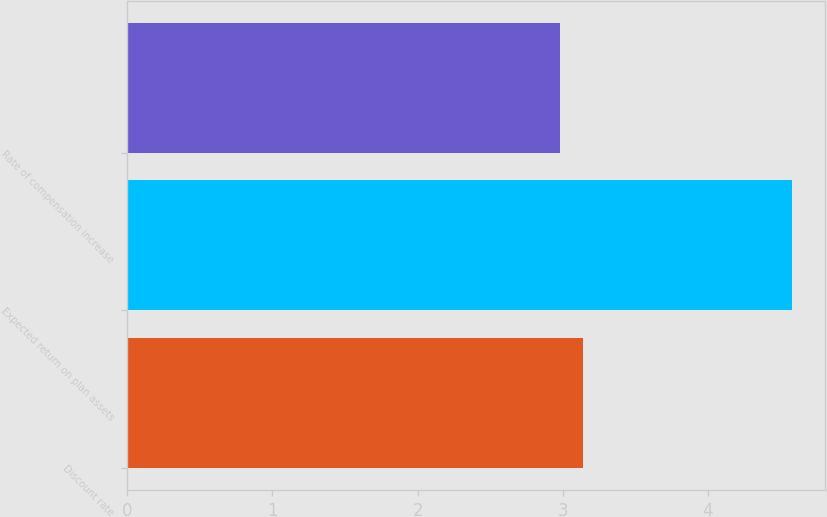Convert chart to OTSL. <chart><loc_0><loc_0><loc_500><loc_500><bar_chart><fcel>Discount rate<fcel>Expected return on plan assets<fcel>Rate of compensation increase<nl><fcel>3.14<fcel>4.58<fcel>2.98<nl></chart> 